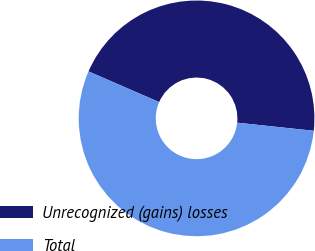Convert chart to OTSL. <chart><loc_0><loc_0><loc_500><loc_500><pie_chart><fcel>Unrecognized (gains) losses<fcel>Total<nl><fcel>45.16%<fcel>54.84%<nl></chart> 